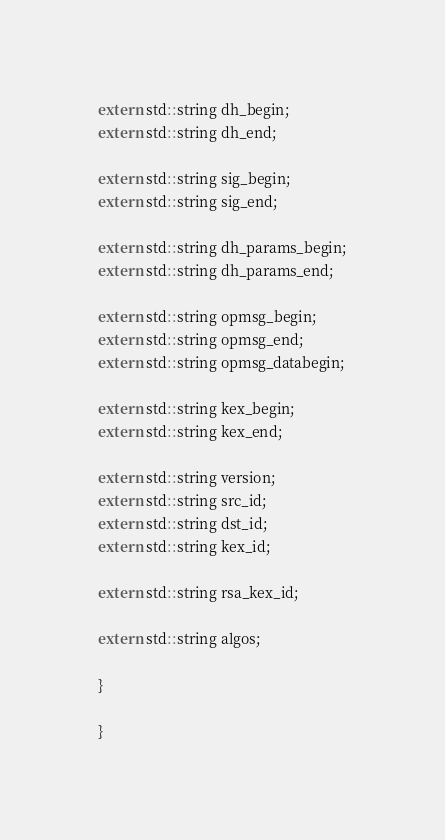<code> <loc_0><loc_0><loc_500><loc_500><_C_>
extern std::string dh_begin;
extern std::string dh_end;

extern std::string sig_begin;
extern std::string sig_end;

extern std::string dh_params_begin;
extern std::string dh_params_end;

extern std::string opmsg_begin;
extern std::string opmsg_end;
extern std::string opmsg_databegin;

extern std::string kex_begin;
extern std::string kex_end;

extern std::string version;
extern std::string src_id;
extern std::string dst_id;
extern std::string kex_id;

extern std::string rsa_kex_id;

extern std::string algos;

}

}

</code> 